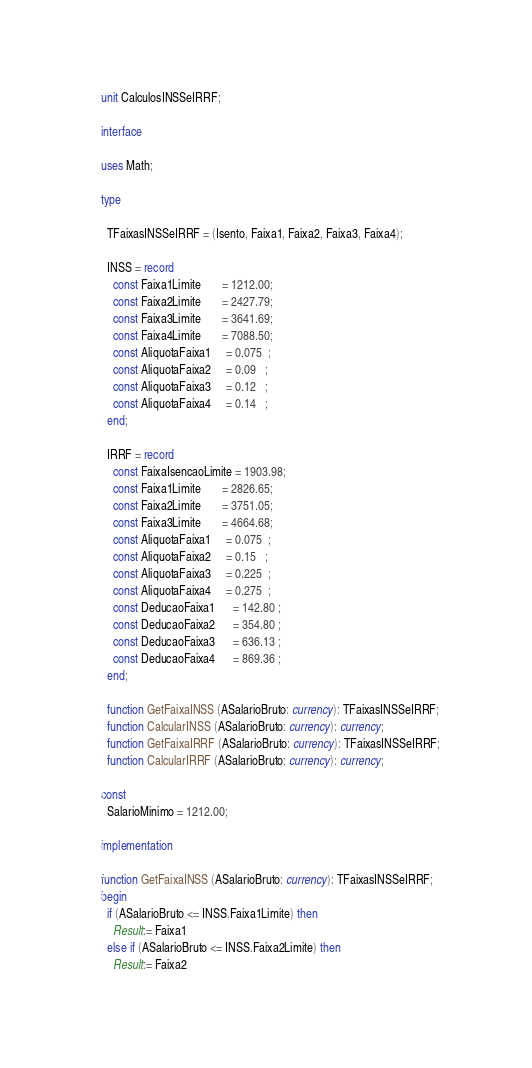Convert code to text. <code><loc_0><loc_0><loc_500><loc_500><_Pascal_>unit CalculosINSSeIRRF;

interface

uses Math;

type

  TFaixasINSSeIRRF = (Isento, Faixa1, Faixa2, Faixa3, Faixa4);

  INSS = record
    const Faixa1Limite       = 1212.00;
    const Faixa2Limite       = 2427.79;
    const Faixa3Limite       = 3641.69;
    const Faixa4Limite       = 7088.50;
    const AliquotaFaixa1     = 0.075  ;
    const AliquotaFaixa2     = 0.09   ;
    const AliquotaFaixa3     = 0.12   ;
    const AliquotaFaixa4     = 0.14   ;
  end;

  IRRF = record
    const FaixaIsencaoLimite = 1903.98;
    const Faixa1Limite       = 2826.65;
    const Faixa2Limite       = 3751.05;
    const Faixa3Limite       = 4664.68;
    const AliquotaFaixa1     = 0.075  ;
    const AliquotaFaixa2     = 0.15   ;
    const AliquotaFaixa3     = 0.225  ;
    const AliquotaFaixa4     = 0.275  ;
    const DeducaoFaixa1      = 142.80 ;
    const DeducaoFaixa2      = 354.80 ;
    const DeducaoFaixa3      = 636.13 ;
    const DeducaoFaixa4      = 869.36 ;
  end;

  function GetFaixaINSS (ASalarioBruto: currency): TFaixasINSSeIRRF;
  function CalcularINSS (ASalarioBruto: currency): currency;
  function GetFaixaIRRF (ASalarioBruto: currency): TFaixasINSSeIRRF;
  function CalcularIRRF (ASalarioBruto: currency): currency;

const
  SalarioMinimo = 1212.00;

implementation

function GetFaixaINSS (ASalarioBruto: currency): TFaixasINSSeIRRF;
begin
  if (ASalarioBruto <= INSS.Faixa1Limite) then
    Result:= Faixa1
  else if (ASalarioBruto <= INSS.Faixa2Limite) then
    Result:= Faixa2</code> 